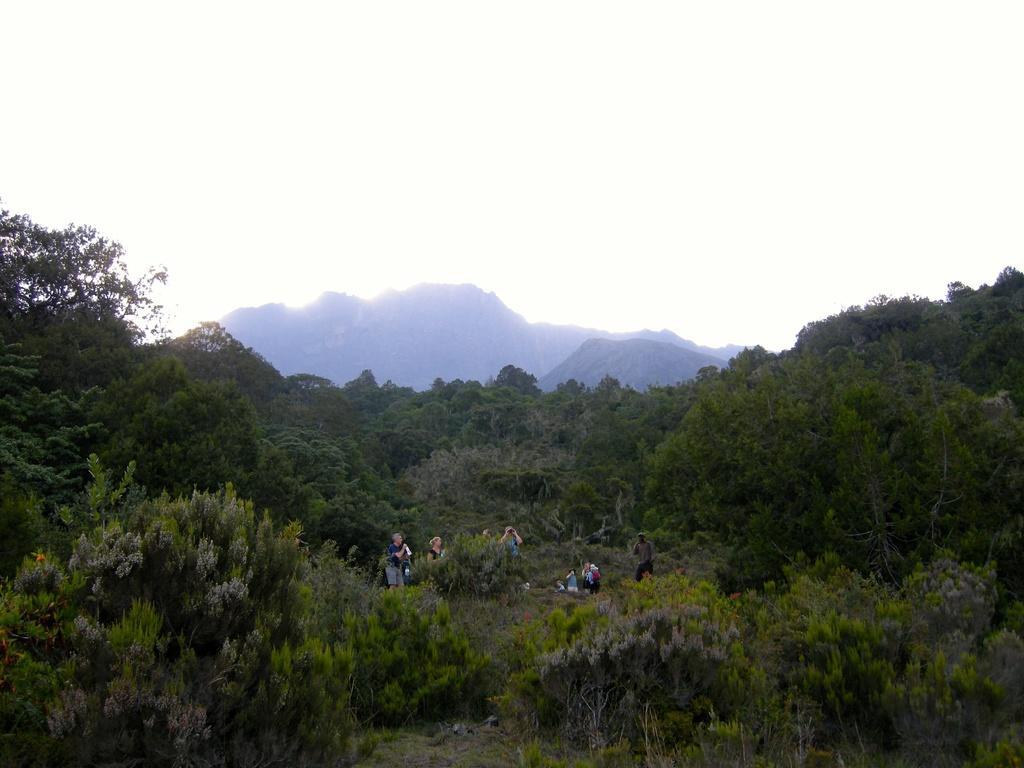How would you summarize this image in a sentence or two? In this image, I see lot of trees and a group of people over here. In the background I can see mountains. 